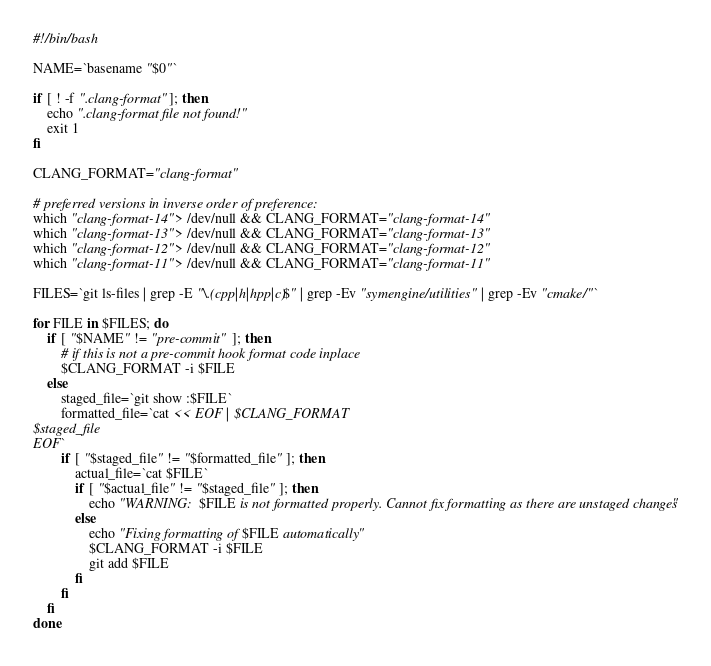<code> <loc_0><loc_0><loc_500><loc_500><_Bash_>#!/bin/bash

NAME=`basename "$0"`

if [ ! -f ".clang-format" ]; then
    echo ".clang-format file not found!"
    exit 1
fi

CLANG_FORMAT="clang-format"

# preferred versions in inverse order of preference:
which "clang-format-14" > /dev/null && CLANG_FORMAT="clang-format-14"
which "clang-format-13" > /dev/null && CLANG_FORMAT="clang-format-13"
which "clang-format-12" > /dev/null && CLANG_FORMAT="clang-format-12"
which "clang-format-11" > /dev/null && CLANG_FORMAT="clang-format-11"

FILES=`git ls-files | grep -E "\.(cpp|h|hpp|c)$" | grep -Ev "symengine/utilities" | grep -Ev "cmake/"`

for FILE in $FILES; do
    if [ "$NAME" != "pre-commit" ]; then
        # if this is not a pre-commit hook format code inplace
        $CLANG_FORMAT -i $FILE
    else
        staged_file=`git show :$FILE`
        formatted_file=`cat << EOF | $CLANG_FORMAT
$staged_file
EOF`
        if [ "$staged_file" != "$formatted_file" ]; then
            actual_file=`cat $FILE`
            if [ "$actual_file" != "$staged_file" ]; then
                echo "WARNING: $FILE is not formatted properly. Cannot fix formatting as there are unstaged changes"
            else
                echo "Fixing formatting of $FILE automatically"
                $CLANG_FORMAT -i $FILE
                git add $FILE
            fi
        fi
    fi
done

</code> 